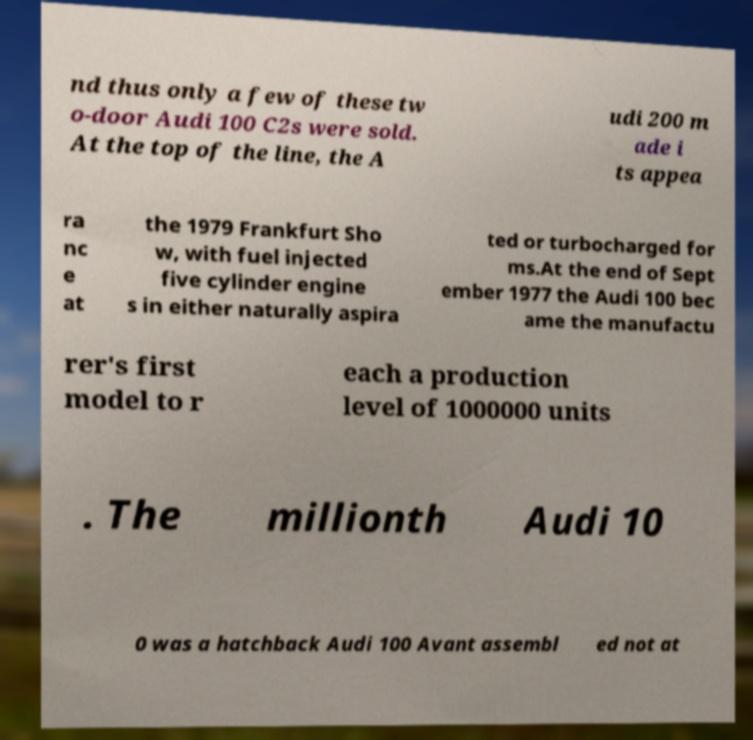Please read and relay the text visible in this image. What does it say? nd thus only a few of these tw o-door Audi 100 C2s were sold. At the top of the line, the A udi 200 m ade i ts appea ra nc e at the 1979 Frankfurt Sho w, with fuel injected five cylinder engine s in either naturally aspira ted or turbocharged for ms.At the end of Sept ember 1977 the Audi 100 bec ame the manufactu rer's first model to r each a production level of 1000000 units . The millionth Audi 10 0 was a hatchback Audi 100 Avant assembl ed not at 